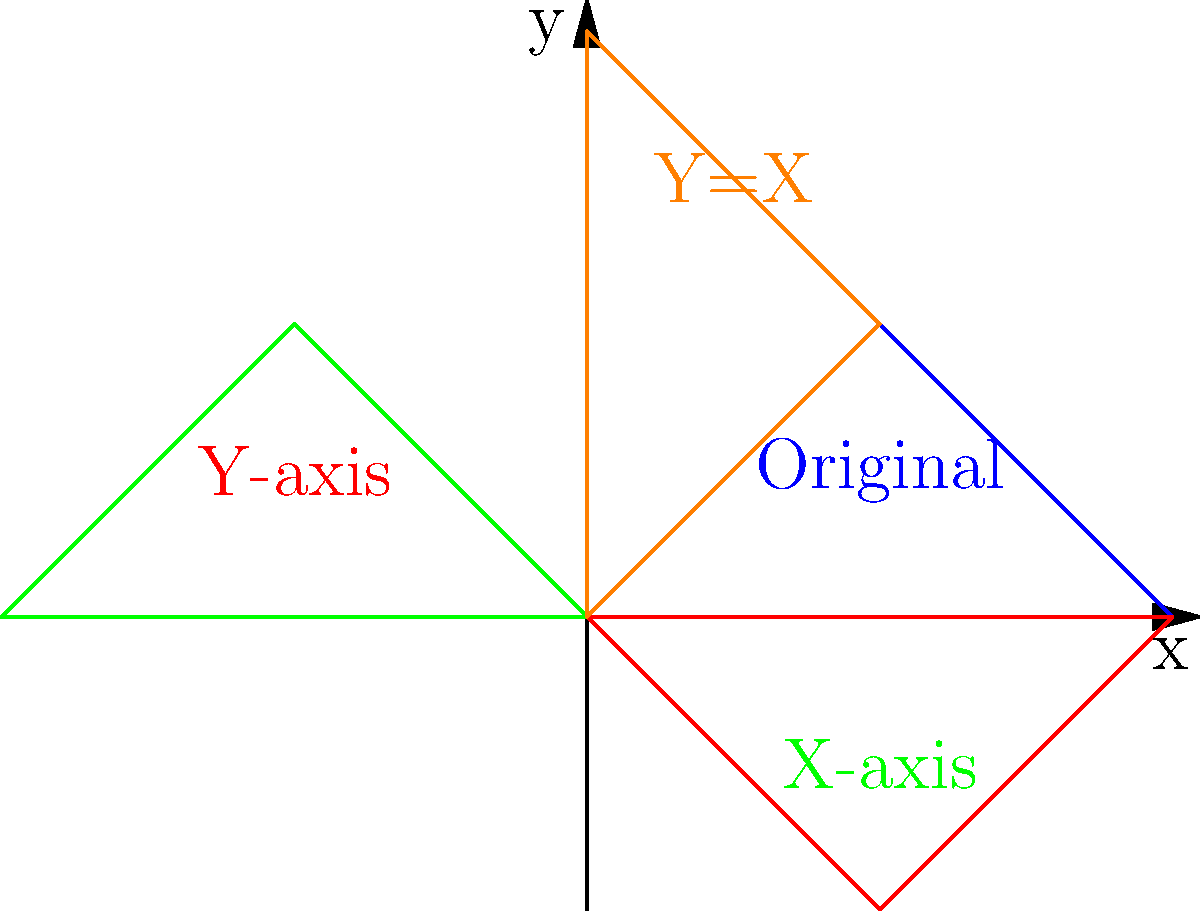A child's drawing of a triangle is reflected across multiple axes to represent different perspectives in therapy. If the original triangle has coordinates $A(0,0)$, $B(1,1)$, and $C(2,0)$, what are the coordinates of point B after reflecting across the y-axis, then the x-axis, and finally across the line $y=x$? Let's approach this step-by-step:

1) Original coordinates of B: $(1,1)$

2) Reflection across y-axis:
   $x' = -x$, $y' = y$
   $B_1(-1,1)$

3) Reflection across x-axis:
   $x' = x$, $y' = -y$
   $B_2(-1,-1)$

4) Reflection across $y=x$:
   This swaps x and y coordinates
   $B_3(-1,-1)$ becomes $B_4(-1,-1)$

Therefore, the final coordinates of point B after all reflections are $(-1,-1)$.

This sequence of reflections represents how a psychoanalyst might explore different perspectives of a childhood memory, symbolized by the triangle. Each reflection offers a new viewpoint, potentially uncovering hidden aspects of the patient's psyche.
Answer: $(-1,-1)$ 